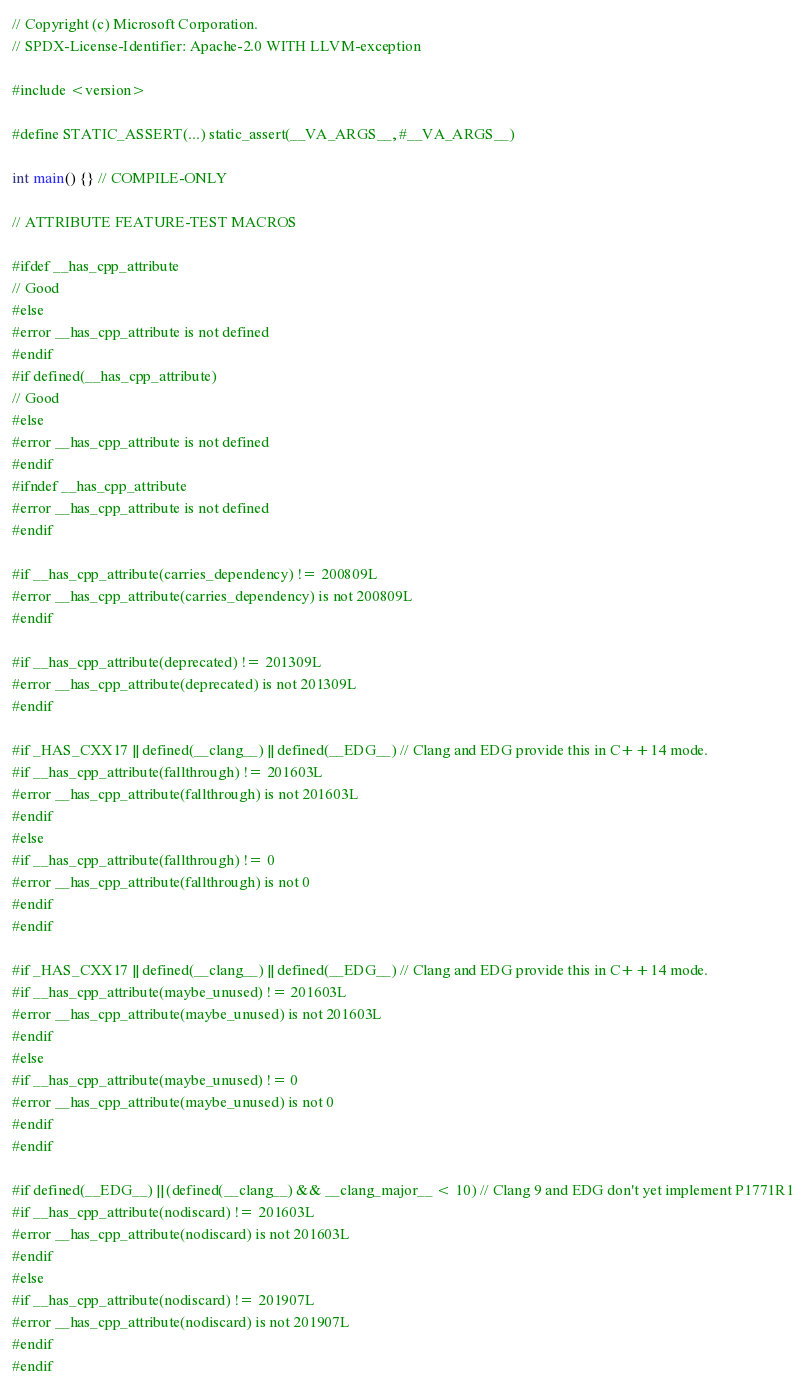Convert code to text. <code><loc_0><loc_0><loc_500><loc_500><_C++_>// Copyright (c) Microsoft Corporation.
// SPDX-License-Identifier: Apache-2.0 WITH LLVM-exception

#include <version>

#define STATIC_ASSERT(...) static_assert(__VA_ARGS__, #__VA_ARGS__)

int main() {} // COMPILE-ONLY

// ATTRIBUTE FEATURE-TEST MACROS

#ifdef __has_cpp_attribute
// Good
#else
#error __has_cpp_attribute is not defined
#endif
#if defined(__has_cpp_attribute)
// Good
#else
#error __has_cpp_attribute is not defined
#endif
#ifndef __has_cpp_attribute
#error __has_cpp_attribute is not defined
#endif

#if __has_cpp_attribute(carries_dependency) != 200809L
#error __has_cpp_attribute(carries_dependency) is not 200809L
#endif

#if __has_cpp_attribute(deprecated) != 201309L
#error __has_cpp_attribute(deprecated) is not 201309L
#endif

#if _HAS_CXX17 || defined(__clang__) || defined(__EDG__) // Clang and EDG provide this in C++14 mode.
#if __has_cpp_attribute(fallthrough) != 201603L
#error __has_cpp_attribute(fallthrough) is not 201603L
#endif
#else
#if __has_cpp_attribute(fallthrough) != 0
#error __has_cpp_attribute(fallthrough) is not 0
#endif
#endif

#if _HAS_CXX17 || defined(__clang__) || defined(__EDG__) // Clang and EDG provide this in C++14 mode.
#if __has_cpp_attribute(maybe_unused) != 201603L
#error __has_cpp_attribute(maybe_unused) is not 201603L
#endif
#else
#if __has_cpp_attribute(maybe_unused) != 0
#error __has_cpp_attribute(maybe_unused) is not 0
#endif
#endif

#if defined(__EDG__) || (defined(__clang__) && __clang_major__ < 10) // Clang 9 and EDG don't yet implement P1771R1
#if __has_cpp_attribute(nodiscard) != 201603L
#error __has_cpp_attribute(nodiscard) is not 201603L
#endif
#else
#if __has_cpp_attribute(nodiscard) != 201907L
#error __has_cpp_attribute(nodiscard) is not 201907L
#endif
#endif
</code> 